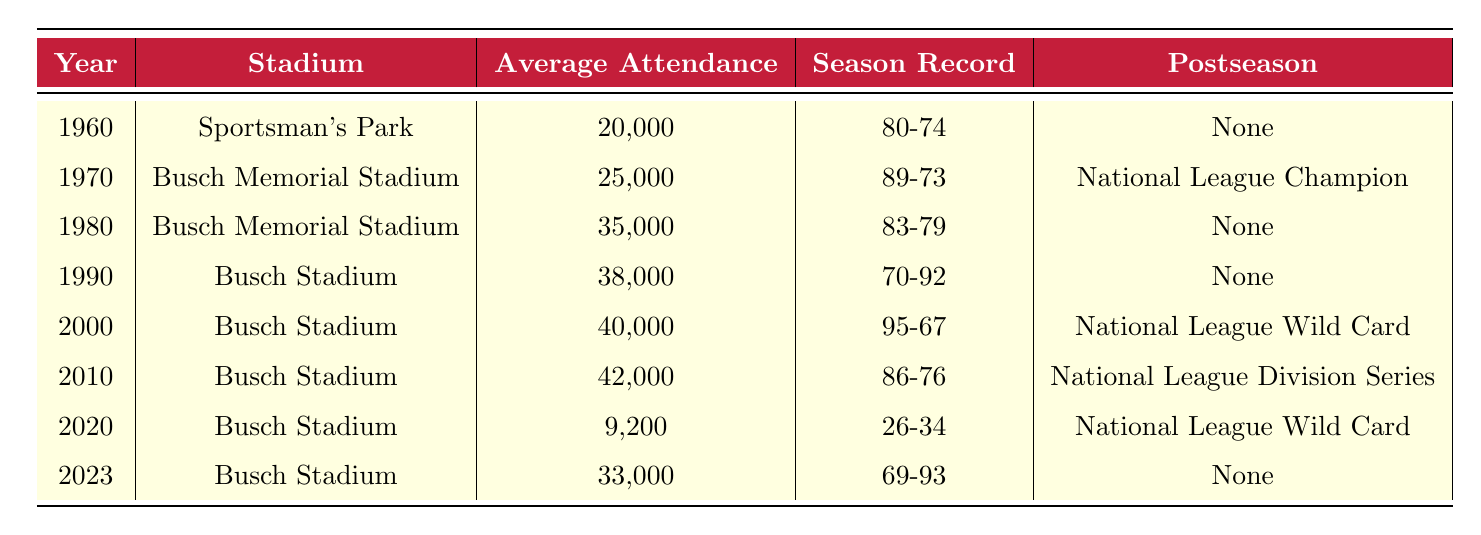What was the average attendance for the St. Louis Cardinals in 1980? The table shows that the average attendance for the St. Louis Cardinals in 1980 was 35,000. This value is found directly in the row corresponding to the year 1980.
Answer: 35,000 In which year did the St. Louis Cardinals last make the postseason according to the table? Looking through the rows, the last postseason appearance for the St. Louis Cardinals noted in the table was in 2010, where they participated in the National League Division Series. This information comes from the row for that year.
Answer: 2010 What is the difference in average attendance between 2000 and 2023? The average attendance in 2000 is 40,000 and in 2023 it is 33,000. To find the difference, we subtract 33,000 from 40,000, resulting in a difference of 7,000.
Answer: 7,000 Did the St. Louis Cardinals achieve a winning season in 1990? In 1990, the season record of the St. Louis Cardinals was 70-92, which indicates they lost more games than they won. Therefore, the answer is no.
Answer: No What was the trend in average attendance from 1960 to 2020? Average attendance increased from 20,000 in 1960 to 25,000 in 1970, then further increased to 35,000 in 1980 and 38,000 in 1990. In 2000, it increased to 40,000 and to 42,000 in 2010. However, in 2020, it dropped significantly to 9,200. This shows a general upward trend for the first 60 years, followed by a dramatic decline in 2020.
Answer: Increasing trend until 2020, then a decline Which stadium had the highest average attendance, and what was that attendance? The stadium with the highest average attendance is Busch Stadium in 2010, with an average attendance of 42,000. This is identified in the row for that year under the Average Attendance column.
Answer: Busch Stadium, 42,000 Was there ever a year when the St. Louis Cardinals had an average attendance below 20,000? The table indicates that the lowest average attendance recorded was 9,200 in 2020. Since this is below 20,000, the answer is yes.
Answer: Yes How many years did the St. Louis Cardinals have an average attendance of over 30,000? By examining the data, the years with an average attendance over 30,000 are 1980 (35,000), 1990 (38,000), 2000 (40,000), 2010 (42,000), and 2023 (33,000). This totals 5 years where the attendance was above 30,000.
Answer: 5 What was the highest season win-loss record for the St. Louis Cardinals noted in the table? The season win-loss record with the highest wins and lowest losses is 95-67 in the year 2000, which can be found in the corresponding row for that year.
Answer: 95-67 